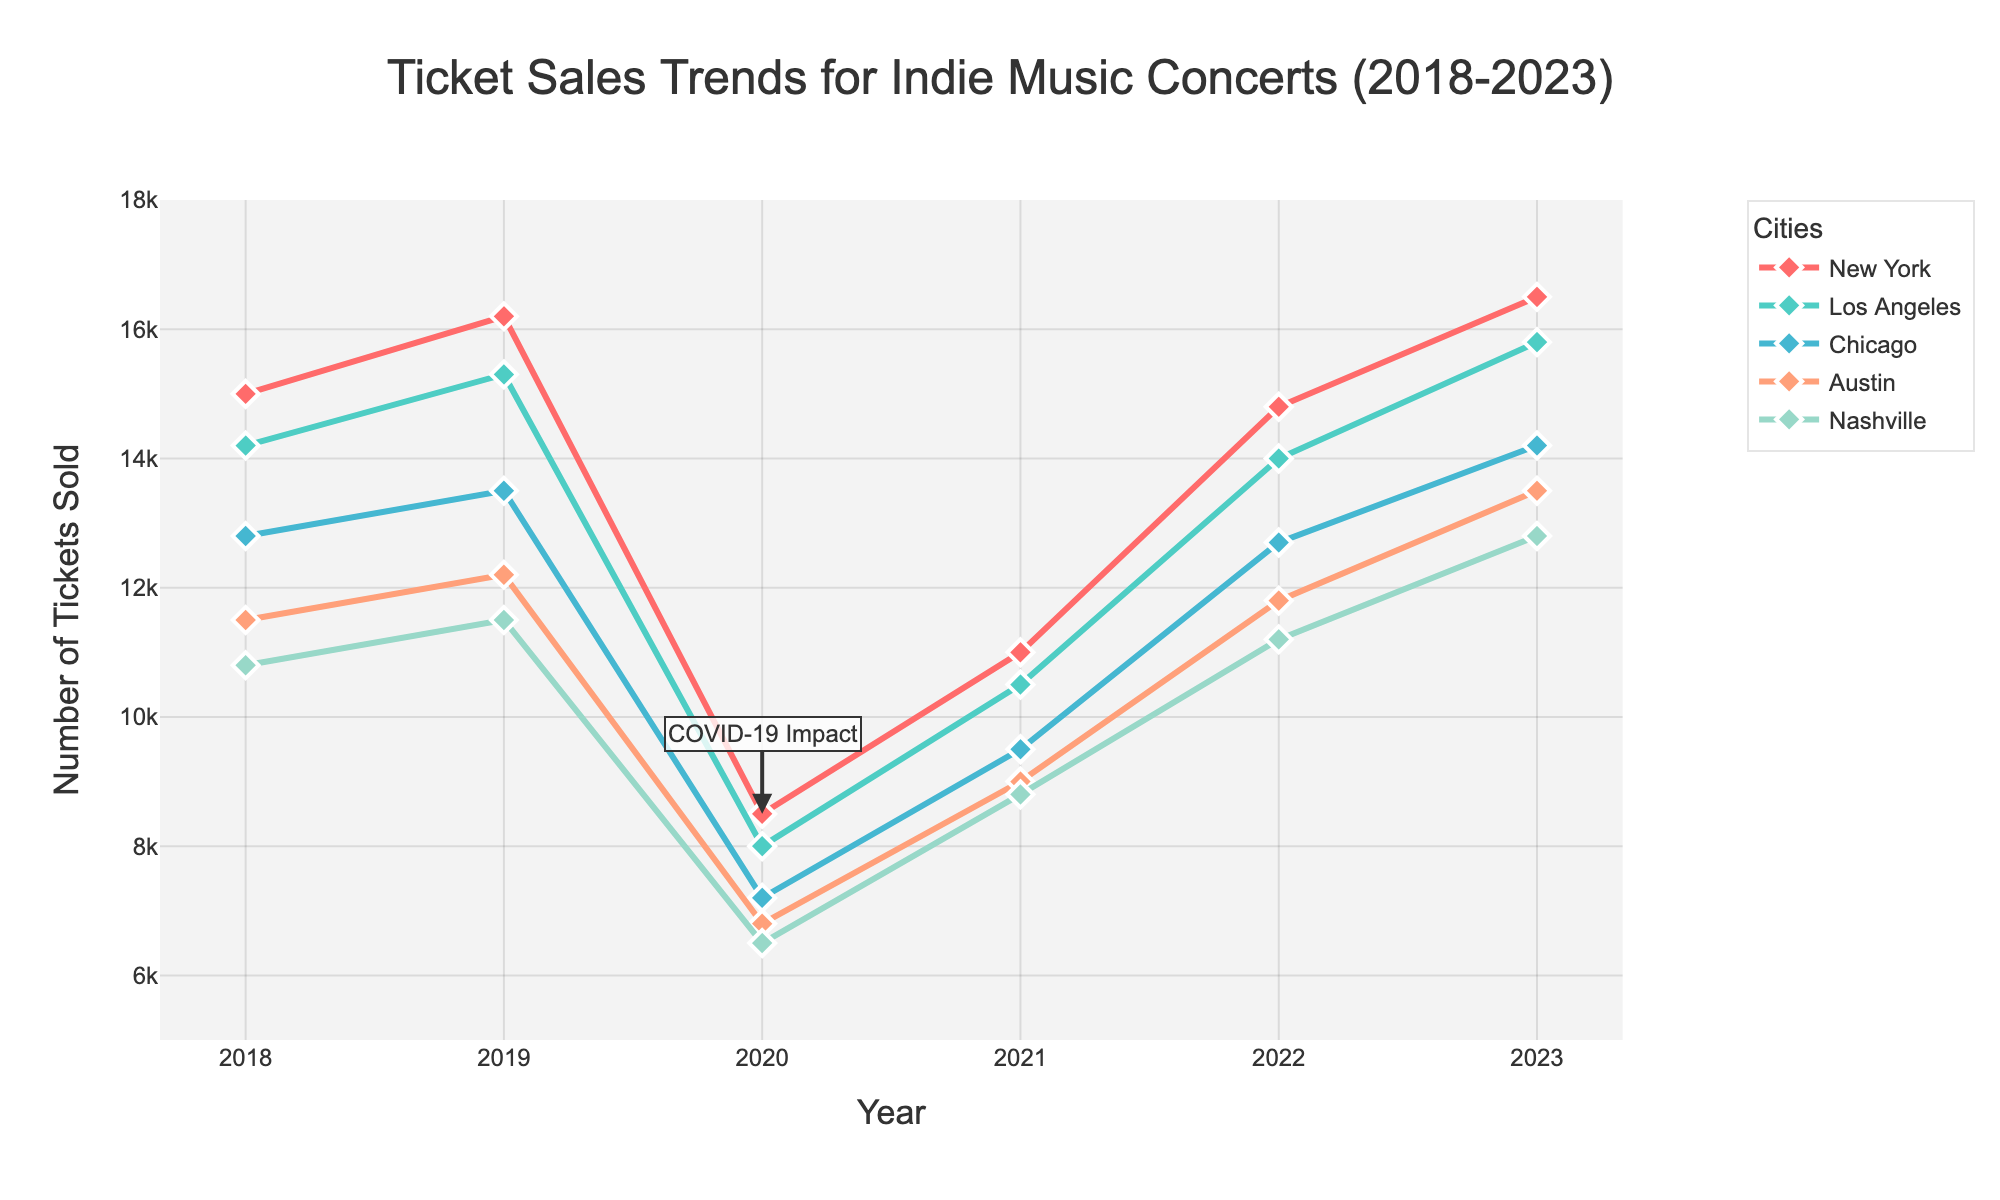Which city sold the most tickets in 2023? Look at the ticket sales for each city in 2023 and compare the values. New York has the highest number with 16500 tickets sold.
Answer: New York How did ticket sales in Los Angeles change from 2020 to 2021? Compare the ticket sales in Los Angeles for the two years. In 2020, Los Angeles sold 8000 tickets, and in 2021, it increased to 10500.
Answer: Increased by 2500 What is the average number of tickets sold in Austin across all years? Add the number of tickets sold in Austin for each year and divide by the number of years (11500 + 12200 + 6800 + 9000 + 11800 + 13500). The sum is 64800 and there are 6 years.
Answer: 10800 Which city had the least decline in ticket sales between 2019 and 2020? Calculate the decline for each city by subtracting the 2020 value from the 2019 value. New York (16200 - 8500 = 7700), Los Angeles (15300 - 8000 = 7300), Chicago (13500 - 7200 = 6300), Austin (12200 - 6800 = 5400), Nashville (11500 - 6500 = 5000). The least decline is in Nashville.
Answer: Nashville In which year did ticket sales start to recover after the impact of COVID-19, and how can you tell? Observe the trend lines after 2020. All cities show an increase in ticket sales in 2021 compared to 2020, indicating the start of recovery.
Answer: 2021 What city had the largest increase in ticket sales between 2021 and 2022? Calculate the difference between the 2021 and 2022 ticket sales for each city. New York (14800 - 11000 = 3800), Los Angeles (14000 - 10500 = 3500), Chicago (12700 - 9500 = 3200), Austin (11800 - 9000 = 2800), Nashville (11200 - 8800 = 2400). The largest increase is in New York.
Answer: New York What specific visual cue indicates the impact of COVID-19 on ticket sales? Identify any annotations or specific markers. The annotation labeled "COVID-19 Impact" at 2020 indicates a significant drop in sales due to the pandemic.
Answer: Annotation labeled "COVID-19 Impact" How do the ticket sales in Nashville for 2023 compare to Austin for the same year? Look at the 2023 ticket sales values for both Nashville (12800) and Austin (13500). Compare the two values.
Answer: Austin is higher by 700 tickets Which city had the most consistent ticket sales trend over the years and how? Compare the fluctuation in the trend lines of each city. Austin shows a smoother and more consistent trend compared to others with minimal fluctuations.
Answer: Austin 